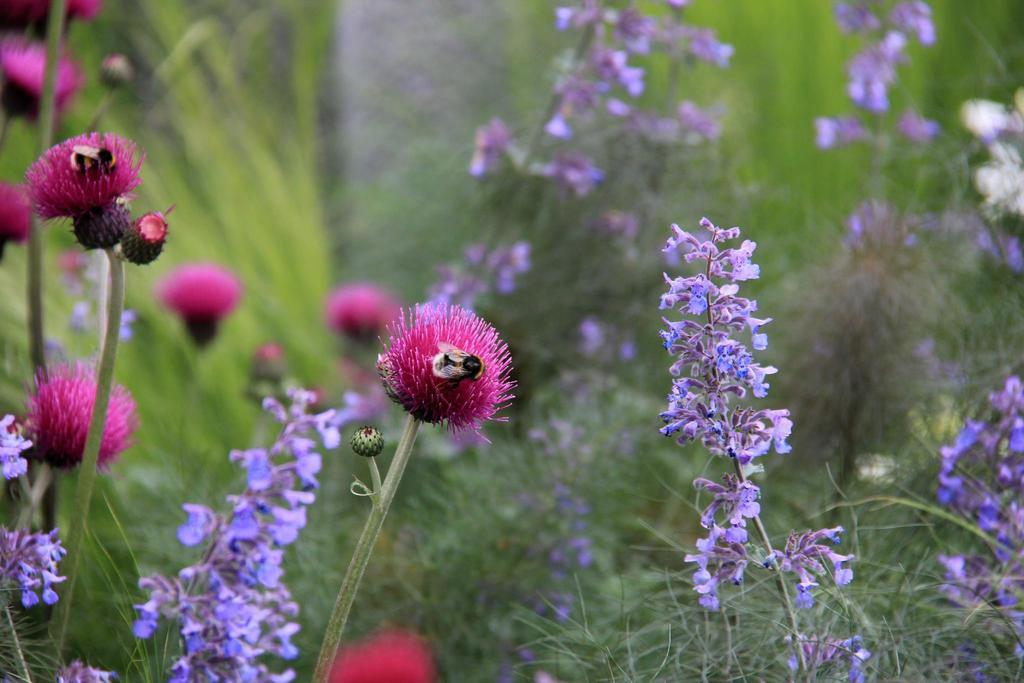What type of plants can be seen in the front of the image? There are flower plants in the front of the image. What else is present in the front of the image? There are insects in the front of the image. Can you describe the background of the image? The background of the image is blurry. How does the manager interact with the fifth insect in the image? There is no manager present in the image, and therefore no interaction with any insects can be observed. 